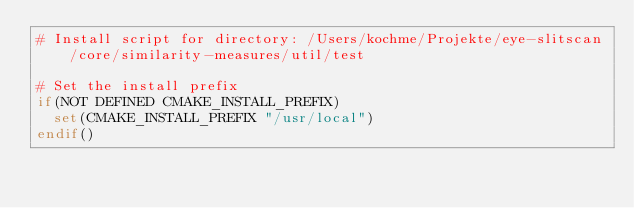Convert code to text. <code><loc_0><loc_0><loc_500><loc_500><_CMake_># Install script for directory: /Users/kochme/Projekte/eye-slitscan/core/similarity-measures/util/test

# Set the install prefix
if(NOT DEFINED CMAKE_INSTALL_PREFIX)
  set(CMAKE_INSTALL_PREFIX "/usr/local")
endif()</code> 